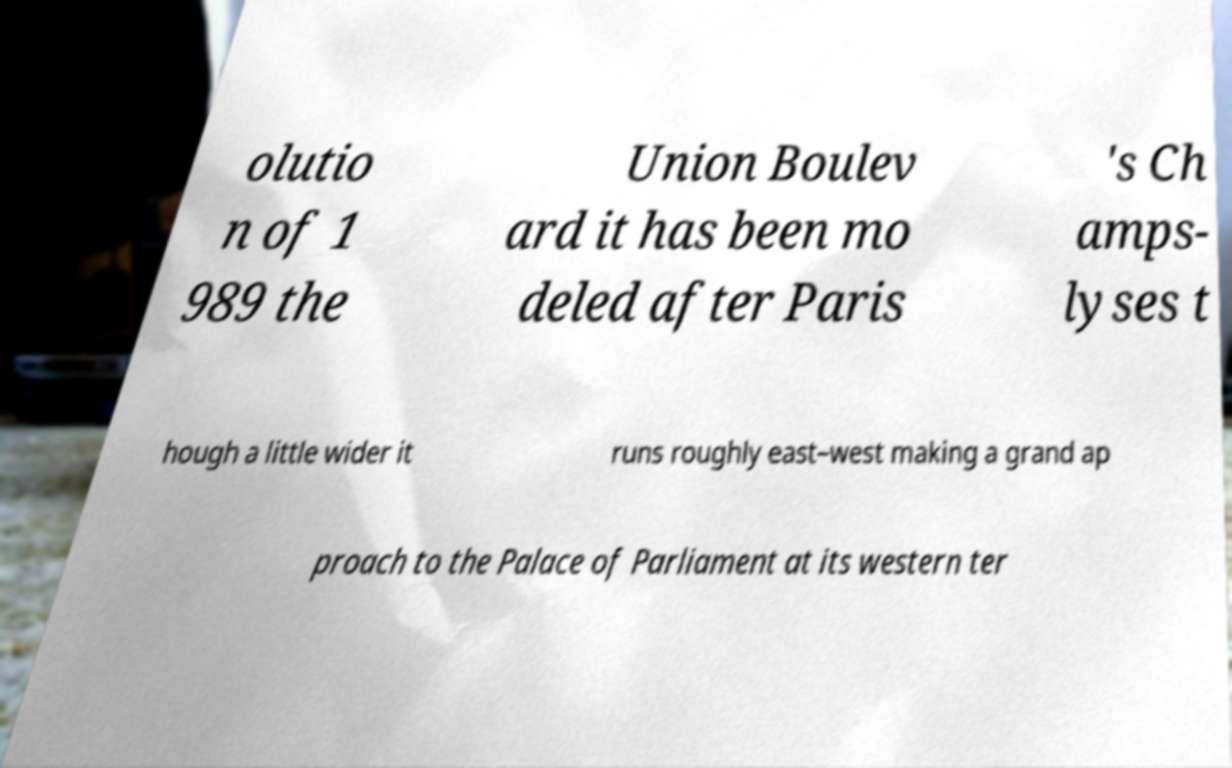Can you accurately transcribe the text from the provided image for me? olutio n of 1 989 the Union Boulev ard it has been mo deled after Paris 's Ch amps- lyses t hough a little wider it runs roughly east–west making a grand ap proach to the Palace of Parliament at its western ter 